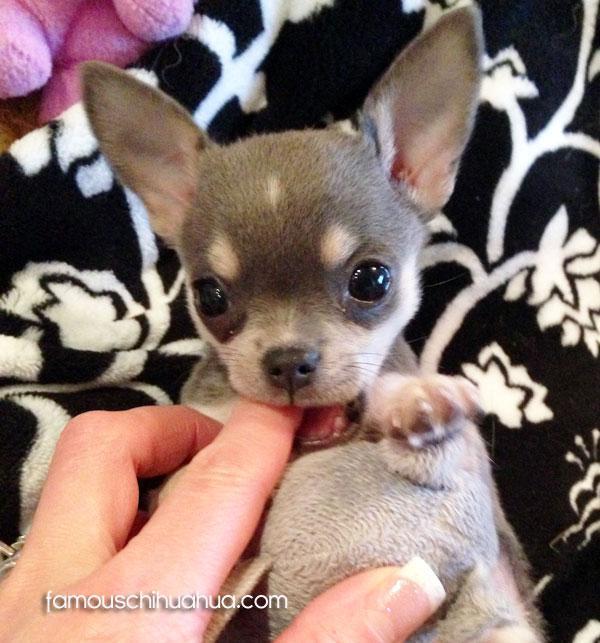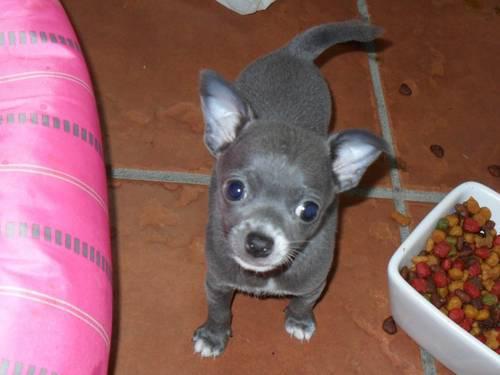The first image is the image on the left, the second image is the image on the right. Evaluate the accuracy of this statement regarding the images: "One of the dogs is sticking it's tongue out of a closed mouth.". Is it true? Answer yes or no. No. 